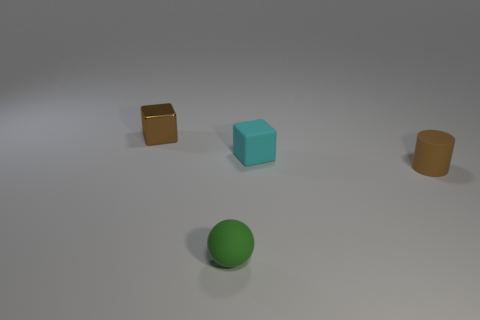Add 4 green shiny cubes. How many objects exist? 8 Subtract all balls. How many objects are left? 3 Subtract all tiny purple blocks. Subtract all small cylinders. How many objects are left? 3 Add 4 brown metal objects. How many brown metal objects are left? 5 Add 4 green matte objects. How many green matte objects exist? 5 Subtract 1 cyan blocks. How many objects are left? 3 